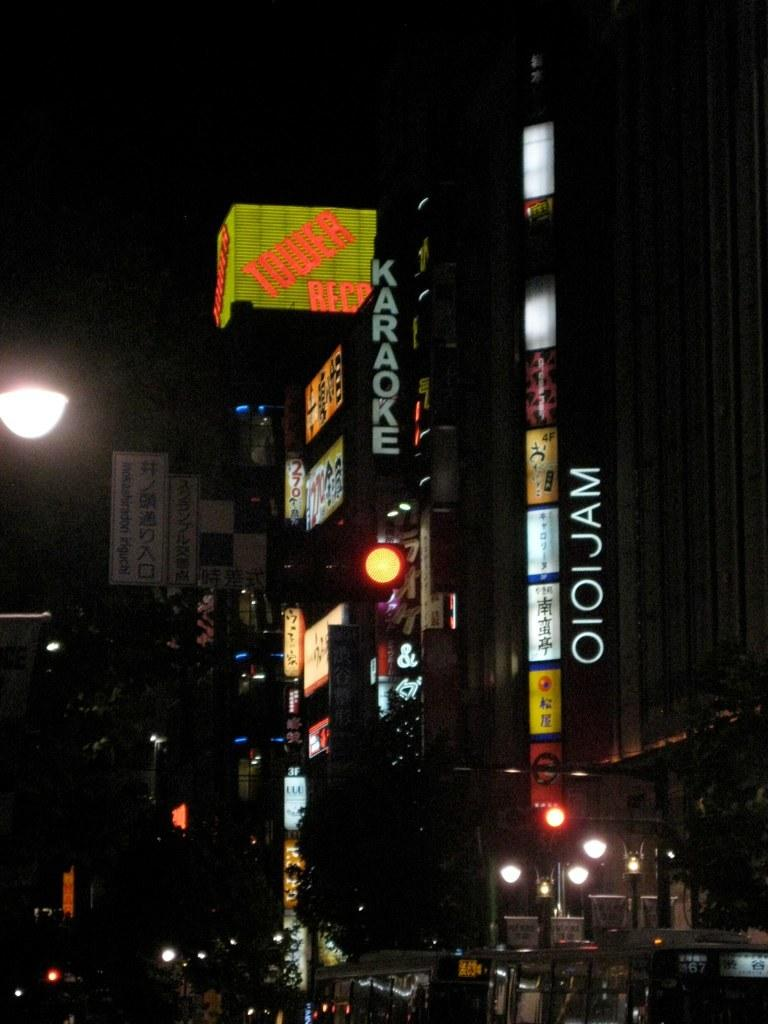What can be seen in the image that indicates human activity? There are many buildings with lights in the image, which suggests human activity. What information can be found on the buildings? There are name boards on the buildings, which provide information about the buildings. Where is the light located in the image? There is a light on the left side of the image. What type of vegetation is present in the image? There are trees in the image. What mode of transportation is visible at the bottom of the image? There is a bus at the bottom of the image. What type of polish is being applied to the sister's nails in the image? There is no mention of polish or a sister in the image, so this question cannot be answered. What journey is the bus taking in the image? The image does not provide information about the bus's journey, so this question cannot be answered. 